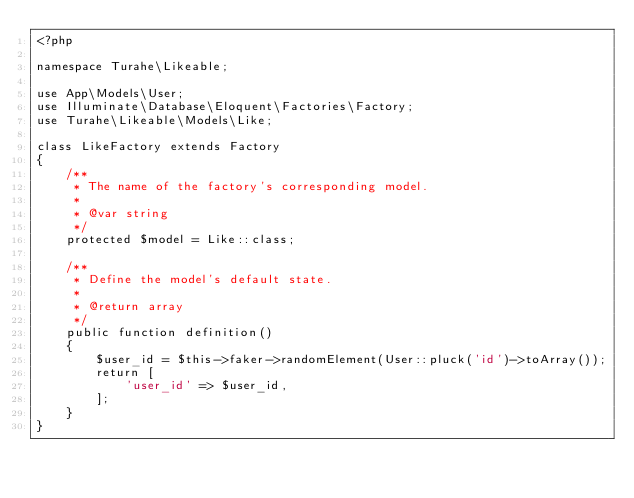<code> <loc_0><loc_0><loc_500><loc_500><_PHP_><?php

namespace Turahe\Likeable;

use App\Models\User;
use Illuminate\Database\Eloquent\Factories\Factory;
use Turahe\Likeable\Models\Like;

class LikeFactory extends Factory
{
    /**
     * The name of the factory's corresponding model.
     *
     * @var string
     */
    protected $model = Like::class;

    /**
     * Define the model's default state.
     *
     * @return array
     */
    public function definition()
    {
        $user_id = $this->faker->randomElement(User::pluck('id')->toArray());
        return [
            'user_id' => $user_id,
        ];
    }
}
</code> 